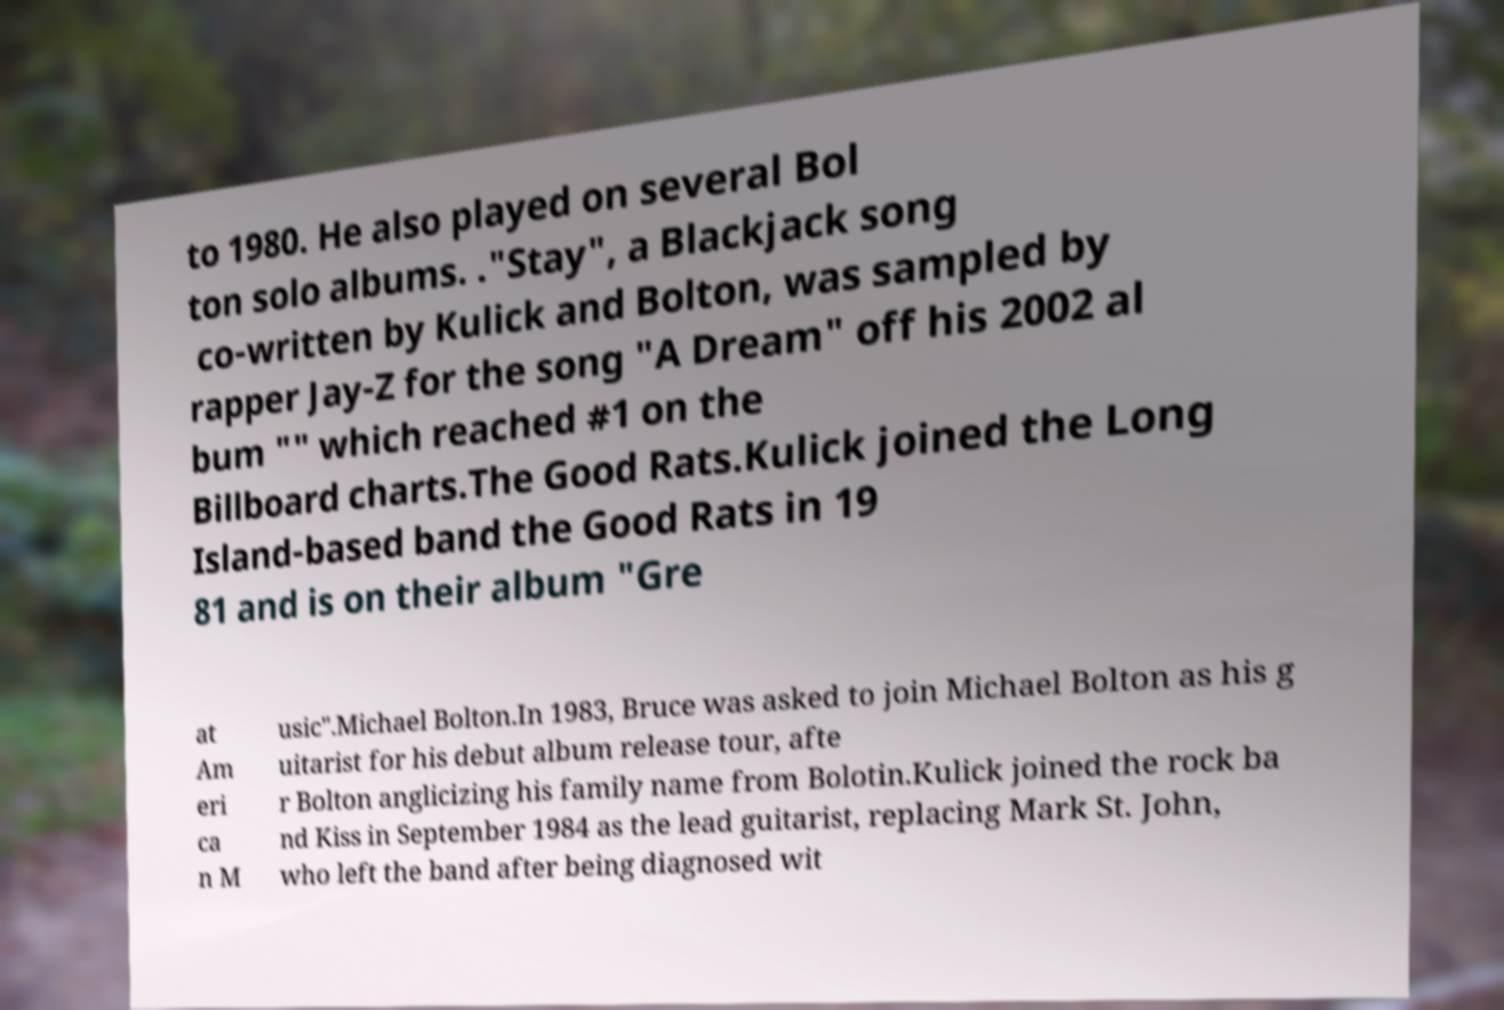I need the written content from this picture converted into text. Can you do that? to 1980. He also played on several Bol ton solo albums. ."Stay", a Blackjack song co-written by Kulick and Bolton, was sampled by rapper Jay-Z for the song "A Dream" off his 2002 al bum "" which reached #1 on the Billboard charts.The Good Rats.Kulick joined the Long Island-based band the Good Rats in 19 81 and is on their album "Gre at Am eri ca n M usic".Michael Bolton.In 1983, Bruce was asked to join Michael Bolton as his g uitarist for his debut album release tour, afte r Bolton anglicizing his family name from Bolotin.Kulick joined the rock ba nd Kiss in September 1984 as the lead guitarist, replacing Mark St. John, who left the band after being diagnosed wit 